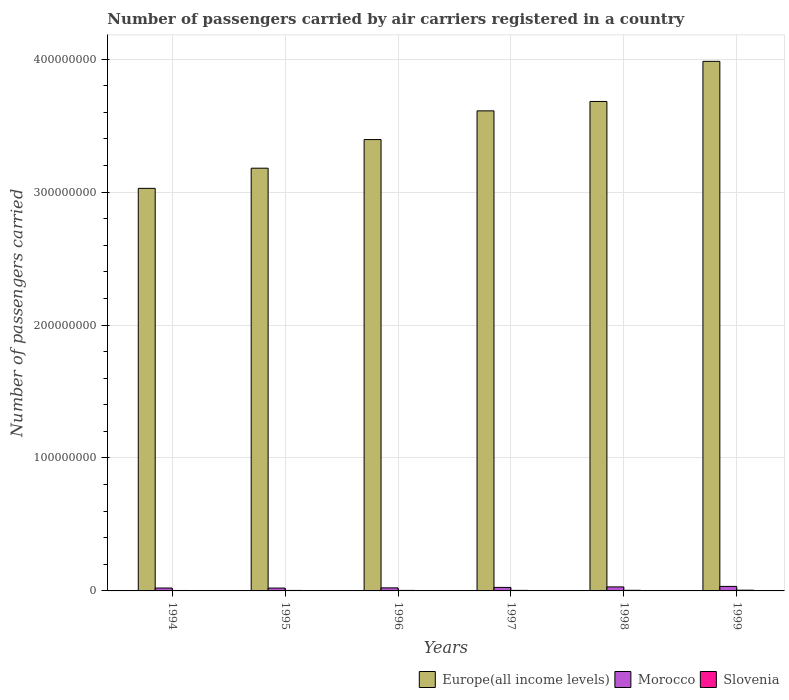How many different coloured bars are there?
Make the answer very short. 3. Are the number of bars per tick equal to the number of legend labels?
Keep it short and to the point. Yes. Are the number of bars on each tick of the X-axis equal?
Provide a short and direct response. Yes. How many bars are there on the 1st tick from the left?
Offer a terse response. 3. What is the label of the 2nd group of bars from the left?
Provide a short and direct response. 1995. What is the number of passengers carried by air carriers in Slovenia in 1995?
Give a very brief answer. 3.71e+05. Across all years, what is the maximum number of passengers carried by air carriers in Morocco?
Provide a succinct answer. 3.39e+06. Across all years, what is the minimum number of passengers carried by air carriers in Slovenia?
Your answer should be compact. 3.40e+05. In which year was the number of passengers carried by air carriers in Slovenia minimum?
Offer a very short reply. 1994. What is the total number of passengers carried by air carriers in Europe(all income levels) in the graph?
Provide a short and direct response. 2.09e+09. What is the difference between the number of passengers carried by air carriers in Europe(all income levels) in 1994 and that in 1997?
Offer a very short reply. -5.83e+07. What is the difference between the number of passengers carried by air carriers in Morocco in 1994 and the number of passengers carried by air carriers in Slovenia in 1995?
Keep it short and to the point. 1.81e+06. What is the average number of passengers carried by air carriers in Europe(all income levels) per year?
Ensure brevity in your answer.  3.48e+08. In the year 1994, what is the difference between the number of passengers carried by air carriers in Slovenia and number of passengers carried by air carriers in Morocco?
Offer a very short reply. -1.84e+06. In how many years, is the number of passengers carried by air carriers in Europe(all income levels) greater than 140000000?
Keep it short and to the point. 6. What is the ratio of the number of passengers carried by air carriers in Morocco in 1997 to that in 1998?
Provide a short and direct response. 0.88. Is the number of passengers carried by air carriers in Slovenia in 1997 less than that in 1998?
Make the answer very short. Yes. Is the difference between the number of passengers carried by air carriers in Slovenia in 1994 and 1995 greater than the difference between the number of passengers carried by air carriers in Morocco in 1994 and 1995?
Provide a succinct answer. No. What is the difference between the highest and the second highest number of passengers carried by air carriers in Morocco?
Your answer should be very brief. 3.80e+05. What is the difference between the highest and the lowest number of passengers carried by air carriers in Morocco?
Your answer should be compact. 1.24e+06. What does the 2nd bar from the left in 1999 represents?
Offer a very short reply. Morocco. What does the 2nd bar from the right in 1997 represents?
Give a very brief answer. Morocco. How many bars are there?
Make the answer very short. 18. Are all the bars in the graph horizontal?
Your answer should be compact. No. How many years are there in the graph?
Your response must be concise. 6. Does the graph contain grids?
Make the answer very short. Yes. Where does the legend appear in the graph?
Keep it short and to the point. Bottom right. How many legend labels are there?
Offer a very short reply. 3. What is the title of the graph?
Provide a short and direct response. Number of passengers carried by air carriers registered in a country. Does "Macao" appear as one of the legend labels in the graph?
Your answer should be very brief. No. What is the label or title of the Y-axis?
Your answer should be very brief. Number of passengers carried. What is the Number of passengers carried in Europe(all income levels) in 1994?
Your response must be concise. 3.03e+08. What is the Number of passengers carried in Morocco in 1994?
Offer a terse response. 2.18e+06. What is the Number of passengers carried of Slovenia in 1994?
Offer a terse response. 3.40e+05. What is the Number of passengers carried of Europe(all income levels) in 1995?
Ensure brevity in your answer.  3.18e+08. What is the Number of passengers carried in Morocco in 1995?
Offer a very short reply. 2.15e+06. What is the Number of passengers carried in Slovenia in 1995?
Ensure brevity in your answer.  3.71e+05. What is the Number of passengers carried in Europe(all income levels) in 1996?
Offer a terse response. 3.40e+08. What is the Number of passengers carried of Morocco in 1996?
Provide a short and direct response. 2.30e+06. What is the Number of passengers carried in Slovenia in 1996?
Ensure brevity in your answer.  3.93e+05. What is the Number of passengers carried in Europe(all income levels) in 1997?
Give a very brief answer. 3.61e+08. What is the Number of passengers carried of Morocco in 1997?
Keep it short and to the point. 2.64e+06. What is the Number of passengers carried in Slovenia in 1997?
Provide a short and direct response. 4.04e+05. What is the Number of passengers carried of Europe(all income levels) in 1998?
Offer a very short reply. 3.68e+08. What is the Number of passengers carried of Morocco in 1998?
Keep it short and to the point. 3.01e+06. What is the Number of passengers carried of Slovenia in 1998?
Give a very brief answer. 4.60e+05. What is the Number of passengers carried in Europe(all income levels) in 1999?
Ensure brevity in your answer.  3.98e+08. What is the Number of passengers carried in Morocco in 1999?
Keep it short and to the point. 3.39e+06. What is the Number of passengers carried of Slovenia in 1999?
Offer a very short reply. 5.56e+05. Across all years, what is the maximum Number of passengers carried in Europe(all income levels)?
Offer a very short reply. 3.98e+08. Across all years, what is the maximum Number of passengers carried in Morocco?
Offer a terse response. 3.39e+06. Across all years, what is the maximum Number of passengers carried in Slovenia?
Offer a terse response. 5.56e+05. Across all years, what is the minimum Number of passengers carried of Europe(all income levels)?
Your response must be concise. 3.03e+08. Across all years, what is the minimum Number of passengers carried in Morocco?
Keep it short and to the point. 2.15e+06. Across all years, what is the minimum Number of passengers carried in Slovenia?
Provide a short and direct response. 3.40e+05. What is the total Number of passengers carried of Europe(all income levels) in the graph?
Your response must be concise. 2.09e+09. What is the total Number of passengers carried of Morocco in the graph?
Provide a succinct answer. 1.57e+07. What is the total Number of passengers carried of Slovenia in the graph?
Your response must be concise. 2.52e+06. What is the difference between the Number of passengers carried in Europe(all income levels) in 1994 and that in 1995?
Your response must be concise. -1.52e+07. What is the difference between the Number of passengers carried in Morocco in 1994 and that in 1995?
Keep it short and to the point. 3.67e+04. What is the difference between the Number of passengers carried in Slovenia in 1994 and that in 1995?
Offer a very short reply. -3.11e+04. What is the difference between the Number of passengers carried of Europe(all income levels) in 1994 and that in 1996?
Provide a succinct answer. -3.67e+07. What is the difference between the Number of passengers carried in Morocco in 1994 and that in 1996?
Your answer should be compact. -1.17e+05. What is the difference between the Number of passengers carried in Slovenia in 1994 and that in 1996?
Offer a terse response. -5.34e+04. What is the difference between the Number of passengers carried of Europe(all income levels) in 1994 and that in 1997?
Provide a short and direct response. -5.83e+07. What is the difference between the Number of passengers carried in Morocco in 1994 and that in 1997?
Keep it short and to the point. -4.54e+05. What is the difference between the Number of passengers carried in Slovenia in 1994 and that in 1997?
Your answer should be compact. -6.42e+04. What is the difference between the Number of passengers carried of Europe(all income levels) in 1994 and that in 1998?
Your answer should be very brief. -6.54e+07. What is the difference between the Number of passengers carried of Morocco in 1994 and that in 1998?
Your answer should be very brief. -8.28e+05. What is the difference between the Number of passengers carried of Slovenia in 1994 and that in 1998?
Make the answer very short. -1.20e+05. What is the difference between the Number of passengers carried in Europe(all income levels) in 1994 and that in 1999?
Offer a very short reply. -9.55e+07. What is the difference between the Number of passengers carried of Morocco in 1994 and that in 1999?
Your response must be concise. -1.21e+06. What is the difference between the Number of passengers carried of Slovenia in 1994 and that in 1999?
Ensure brevity in your answer.  -2.16e+05. What is the difference between the Number of passengers carried in Europe(all income levels) in 1995 and that in 1996?
Provide a succinct answer. -2.15e+07. What is the difference between the Number of passengers carried of Morocco in 1995 and that in 1996?
Keep it short and to the point. -1.54e+05. What is the difference between the Number of passengers carried of Slovenia in 1995 and that in 1996?
Your answer should be compact. -2.23e+04. What is the difference between the Number of passengers carried in Europe(all income levels) in 1995 and that in 1997?
Make the answer very short. -4.31e+07. What is the difference between the Number of passengers carried of Morocco in 1995 and that in 1997?
Your answer should be very brief. -4.91e+05. What is the difference between the Number of passengers carried in Slovenia in 1995 and that in 1997?
Your answer should be very brief. -3.31e+04. What is the difference between the Number of passengers carried of Europe(all income levels) in 1995 and that in 1998?
Provide a succinct answer. -5.02e+07. What is the difference between the Number of passengers carried in Morocco in 1995 and that in 1998?
Your answer should be compact. -8.65e+05. What is the difference between the Number of passengers carried of Slovenia in 1995 and that in 1998?
Give a very brief answer. -8.92e+04. What is the difference between the Number of passengers carried in Europe(all income levels) in 1995 and that in 1999?
Provide a short and direct response. -8.04e+07. What is the difference between the Number of passengers carried of Morocco in 1995 and that in 1999?
Give a very brief answer. -1.24e+06. What is the difference between the Number of passengers carried of Slovenia in 1995 and that in 1999?
Provide a short and direct response. -1.85e+05. What is the difference between the Number of passengers carried of Europe(all income levels) in 1996 and that in 1997?
Give a very brief answer. -2.16e+07. What is the difference between the Number of passengers carried in Morocco in 1996 and that in 1997?
Offer a very short reply. -3.37e+05. What is the difference between the Number of passengers carried of Slovenia in 1996 and that in 1997?
Give a very brief answer. -1.08e+04. What is the difference between the Number of passengers carried of Europe(all income levels) in 1996 and that in 1998?
Your response must be concise. -2.87e+07. What is the difference between the Number of passengers carried of Morocco in 1996 and that in 1998?
Provide a succinct answer. -7.11e+05. What is the difference between the Number of passengers carried of Slovenia in 1996 and that in 1998?
Offer a terse response. -6.69e+04. What is the difference between the Number of passengers carried in Europe(all income levels) in 1996 and that in 1999?
Offer a terse response. -5.88e+07. What is the difference between the Number of passengers carried of Morocco in 1996 and that in 1999?
Provide a short and direct response. -1.09e+06. What is the difference between the Number of passengers carried in Slovenia in 1996 and that in 1999?
Provide a succinct answer. -1.62e+05. What is the difference between the Number of passengers carried in Europe(all income levels) in 1997 and that in 1998?
Provide a short and direct response. -7.08e+06. What is the difference between the Number of passengers carried in Morocco in 1997 and that in 1998?
Make the answer very short. -3.74e+05. What is the difference between the Number of passengers carried of Slovenia in 1997 and that in 1998?
Give a very brief answer. -5.61e+04. What is the difference between the Number of passengers carried in Europe(all income levels) in 1997 and that in 1999?
Your response must be concise. -3.72e+07. What is the difference between the Number of passengers carried of Morocco in 1997 and that in 1999?
Provide a succinct answer. -7.54e+05. What is the difference between the Number of passengers carried in Slovenia in 1997 and that in 1999?
Offer a terse response. -1.52e+05. What is the difference between the Number of passengers carried of Europe(all income levels) in 1998 and that in 1999?
Make the answer very short. -3.02e+07. What is the difference between the Number of passengers carried in Morocco in 1998 and that in 1999?
Ensure brevity in your answer.  -3.80e+05. What is the difference between the Number of passengers carried of Slovenia in 1998 and that in 1999?
Your response must be concise. -9.56e+04. What is the difference between the Number of passengers carried in Europe(all income levels) in 1994 and the Number of passengers carried in Morocco in 1995?
Ensure brevity in your answer.  3.01e+08. What is the difference between the Number of passengers carried of Europe(all income levels) in 1994 and the Number of passengers carried of Slovenia in 1995?
Your response must be concise. 3.02e+08. What is the difference between the Number of passengers carried of Morocco in 1994 and the Number of passengers carried of Slovenia in 1995?
Your answer should be very brief. 1.81e+06. What is the difference between the Number of passengers carried in Europe(all income levels) in 1994 and the Number of passengers carried in Morocco in 1996?
Provide a succinct answer. 3.01e+08. What is the difference between the Number of passengers carried in Europe(all income levels) in 1994 and the Number of passengers carried in Slovenia in 1996?
Provide a short and direct response. 3.02e+08. What is the difference between the Number of passengers carried of Morocco in 1994 and the Number of passengers carried of Slovenia in 1996?
Your answer should be compact. 1.79e+06. What is the difference between the Number of passengers carried in Europe(all income levels) in 1994 and the Number of passengers carried in Morocco in 1997?
Give a very brief answer. 3.00e+08. What is the difference between the Number of passengers carried of Europe(all income levels) in 1994 and the Number of passengers carried of Slovenia in 1997?
Your answer should be very brief. 3.02e+08. What is the difference between the Number of passengers carried in Morocco in 1994 and the Number of passengers carried in Slovenia in 1997?
Offer a very short reply. 1.78e+06. What is the difference between the Number of passengers carried in Europe(all income levels) in 1994 and the Number of passengers carried in Morocco in 1998?
Your answer should be very brief. 3.00e+08. What is the difference between the Number of passengers carried in Europe(all income levels) in 1994 and the Number of passengers carried in Slovenia in 1998?
Make the answer very short. 3.02e+08. What is the difference between the Number of passengers carried of Morocco in 1994 and the Number of passengers carried of Slovenia in 1998?
Offer a terse response. 1.72e+06. What is the difference between the Number of passengers carried of Europe(all income levels) in 1994 and the Number of passengers carried of Morocco in 1999?
Your answer should be very brief. 2.99e+08. What is the difference between the Number of passengers carried of Europe(all income levels) in 1994 and the Number of passengers carried of Slovenia in 1999?
Your response must be concise. 3.02e+08. What is the difference between the Number of passengers carried of Morocco in 1994 and the Number of passengers carried of Slovenia in 1999?
Make the answer very short. 1.63e+06. What is the difference between the Number of passengers carried of Europe(all income levels) in 1995 and the Number of passengers carried of Morocco in 1996?
Offer a terse response. 3.16e+08. What is the difference between the Number of passengers carried in Europe(all income levels) in 1995 and the Number of passengers carried in Slovenia in 1996?
Give a very brief answer. 3.18e+08. What is the difference between the Number of passengers carried in Morocco in 1995 and the Number of passengers carried in Slovenia in 1996?
Offer a very short reply. 1.75e+06. What is the difference between the Number of passengers carried of Europe(all income levels) in 1995 and the Number of passengers carried of Morocco in 1997?
Offer a very short reply. 3.15e+08. What is the difference between the Number of passengers carried in Europe(all income levels) in 1995 and the Number of passengers carried in Slovenia in 1997?
Keep it short and to the point. 3.18e+08. What is the difference between the Number of passengers carried in Morocco in 1995 and the Number of passengers carried in Slovenia in 1997?
Your answer should be compact. 1.74e+06. What is the difference between the Number of passengers carried in Europe(all income levels) in 1995 and the Number of passengers carried in Morocco in 1998?
Offer a very short reply. 3.15e+08. What is the difference between the Number of passengers carried in Europe(all income levels) in 1995 and the Number of passengers carried in Slovenia in 1998?
Offer a terse response. 3.18e+08. What is the difference between the Number of passengers carried in Morocco in 1995 and the Number of passengers carried in Slovenia in 1998?
Give a very brief answer. 1.69e+06. What is the difference between the Number of passengers carried of Europe(all income levels) in 1995 and the Number of passengers carried of Morocco in 1999?
Provide a short and direct response. 3.15e+08. What is the difference between the Number of passengers carried in Europe(all income levels) in 1995 and the Number of passengers carried in Slovenia in 1999?
Provide a succinct answer. 3.17e+08. What is the difference between the Number of passengers carried in Morocco in 1995 and the Number of passengers carried in Slovenia in 1999?
Ensure brevity in your answer.  1.59e+06. What is the difference between the Number of passengers carried in Europe(all income levels) in 1996 and the Number of passengers carried in Morocco in 1997?
Provide a short and direct response. 3.37e+08. What is the difference between the Number of passengers carried in Europe(all income levels) in 1996 and the Number of passengers carried in Slovenia in 1997?
Offer a very short reply. 3.39e+08. What is the difference between the Number of passengers carried of Morocco in 1996 and the Number of passengers carried of Slovenia in 1997?
Offer a very short reply. 1.90e+06. What is the difference between the Number of passengers carried in Europe(all income levels) in 1996 and the Number of passengers carried in Morocco in 1998?
Offer a terse response. 3.37e+08. What is the difference between the Number of passengers carried in Europe(all income levels) in 1996 and the Number of passengers carried in Slovenia in 1998?
Ensure brevity in your answer.  3.39e+08. What is the difference between the Number of passengers carried of Morocco in 1996 and the Number of passengers carried of Slovenia in 1998?
Offer a terse response. 1.84e+06. What is the difference between the Number of passengers carried in Europe(all income levels) in 1996 and the Number of passengers carried in Morocco in 1999?
Your answer should be very brief. 3.36e+08. What is the difference between the Number of passengers carried of Europe(all income levels) in 1996 and the Number of passengers carried of Slovenia in 1999?
Provide a short and direct response. 3.39e+08. What is the difference between the Number of passengers carried of Morocco in 1996 and the Number of passengers carried of Slovenia in 1999?
Ensure brevity in your answer.  1.75e+06. What is the difference between the Number of passengers carried in Europe(all income levels) in 1997 and the Number of passengers carried in Morocco in 1998?
Your answer should be compact. 3.58e+08. What is the difference between the Number of passengers carried of Europe(all income levels) in 1997 and the Number of passengers carried of Slovenia in 1998?
Make the answer very short. 3.61e+08. What is the difference between the Number of passengers carried in Morocco in 1997 and the Number of passengers carried in Slovenia in 1998?
Your response must be concise. 2.18e+06. What is the difference between the Number of passengers carried in Europe(all income levels) in 1997 and the Number of passengers carried in Morocco in 1999?
Your answer should be compact. 3.58e+08. What is the difference between the Number of passengers carried of Europe(all income levels) in 1997 and the Number of passengers carried of Slovenia in 1999?
Make the answer very short. 3.61e+08. What is the difference between the Number of passengers carried in Morocco in 1997 and the Number of passengers carried in Slovenia in 1999?
Make the answer very short. 2.08e+06. What is the difference between the Number of passengers carried of Europe(all income levels) in 1998 and the Number of passengers carried of Morocco in 1999?
Give a very brief answer. 3.65e+08. What is the difference between the Number of passengers carried in Europe(all income levels) in 1998 and the Number of passengers carried in Slovenia in 1999?
Your answer should be very brief. 3.68e+08. What is the difference between the Number of passengers carried in Morocco in 1998 and the Number of passengers carried in Slovenia in 1999?
Ensure brevity in your answer.  2.46e+06. What is the average Number of passengers carried in Europe(all income levels) per year?
Your answer should be very brief. 3.48e+08. What is the average Number of passengers carried of Morocco per year?
Provide a short and direct response. 2.61e+06. What is the average Number of passengers carried of Slovenia per year?
Offer a very short reply. 4.20e+05. In the year 1994, what is the difference between the Number of passengers carried of Europe(all income levels) and Number of passengers carried of Morocco?
Provide a succinct answer. 3.01e+08. In the year 1994, what is the difference between the Number of passengers carried of Europe(all income levels) and Number of passengers carried of Slovenia?
Provide a short and direct response. 3.03e+08. In the year 1994, what is the difference between the Number of passengers carried of Morocco and Number of passengers carried of Slovenia?
Your answer should be compact. 1.84e+06. In the year 1995, what is the difference between the Number of passengers carried in Europe(all income levels) and Number of passengers carried in Morocco?
Offer a very short reply. 3.16e+08. In the year 1995, what is the difference between the Number of passengers carried of Europe(all income levels) and Number of passengers carried of Slovenia?
Give a very brief answer. 3.18e+08. In the year 1995, what is the difference between the Number of passengers carried of Morocco and Number of passengers carried of Slovenia?
Ensure brevity in your answer.  1.78e+06. In the year 1996, what is the difference between the Number of passengers carried in Europe(all income levels) and Number of passengers carried in Morocco?
Make the answer very short. 3.37e+08. In the year 1996, what is the difference between the Number of passengers carried in Europe(all income levels) and Number of passengers carried in Slovenia?
Make the answer very short. 3.39e+08. In the year 1996, what is the difference between the Number of passengers carried in Morocco and Number of passengers carried in Slovenia?
Offer a terse response. 1.91e+06. In the year 1997, what is the difference between the Number of passengers carried in Europe(all income levels) and Number of passengers carried in Morocco?
Make the answer very short. 3.59e+08. In the year 1997, what is the difference between the Number of passengers carried in Europe(all income levels) and Number of passengers carried in Slovenia?
Give a very brief answer. 3.61e+08. In the year 1997, what is the difference between the Number of passengers carried of Morocco and Number of passengers carried of Slovenia?
Provide a short and direct response. 2.23e+06. In the year 1998, what is the difference between the Number of passengers carried of Europe(all income levels) and Number of passengers carried of Morocco?
Provide a succinct answer. 3.65e+08. In the year 1998, what is the difference between the Number of passengers carried in Europe(all income levels) and Number of passengers carried in Slovenia?
Offer a terse response. 3.68e+08. In the year 1998, what is the difference between the Number of passengers carried in Morocco and Number of passengers carried in Slovenia?
Your response must be concise. 2.55e+06. In the year 1999, what is the difference between the Number of passengers carried in Europe(all income levels) and Number of passengers carried in Morocco?
Ensure brevity in your answer.  3.95e+08. In the year 1999, what is the difference between the Number of passengers carried of Europe(all income levels) and Number of passengers carried of Slovenia?
Keep it short and to the point. 3.98e+08. In the year 1999, what is the difference between the Number of passengers carried in Morocco and Number of passengers carried in Slovenia?
Provide a short and direct response. 2.84e+06. What is the ratio of the Number of passengers carried of Europe(all income levels) in 1994 to that in 1995?
Ensure brevity in your answer.  0.95. What is the ratio of the Number of passengers carried in Morocco in 1994 to that in 1995?
Make the answer very short. 1.02. What is the ratio of the Number of passengers carried in Slovenia in 1994 to that in 1995?
Provide a short and direct response. 0.92. What is the ratio of the Number of passengers carried in Europe(all income levels) in 1994 to that in 1996?
Give a very brief answer. 0.89. What is the ratio of the Number of passengers carried of Morocco in 1994 to that in 1996?
Provide a succinct answer. 0.95. What is the ratio of the Number of passengers carried in Slovenia in 1994 to that in 1996?
Give a very brief answer. 0.86. What is the ratio of the Number of passengers carried of Europe(all income levels) in 1994 to that in 1997?
Offer a very short reply. 0.84. What is the ratio of the Number of passengers carried of Morocco in 1994 to that in 1997?
Keep it short and to the point. 0.83. What is the ratio of the Number of passengers carried in Slovenia in 1994 to that in 1997?
Offer a terse response. 0.84. What is the ratio of the Number of passengers carried of Europe(all income levels) in 1994 to that in 1998?
Your answer should be very brief. 0.82. What is the ratio of the Number of passengers carried of Morocco in 1994 to that in 1998?
Make the answer very short. 0.73. What is the ratio of the Number of passengers carried of Slovenia in 1994 to that in 1998?
Keep it short and to the point. 0.74. What is the ratio of the Number of passengers carried in Europe(all income levels) in 1994 to that in 1999?
Your answer should be compact. 0.76. What is the ratio of the Number of passengers carried of Morocco in 1994 to that in 1999?
Offer a terse response. 0.64. What is the ratio of the Number of passengers carried of Slovenia in 1994 to that in 1999?
Make the answer very short. 0.61. What is the ratio of the Number of passengers carried of Europe(all income levels) in 1995 to that in 1996?
Your answer should be very brief. 0.94. What is the ratio of the Number of passengers carried of Morocco in 1995 to that in 1996?
Provide a short and direct response. 0.93. What is the ratio of the Number of passengers carried of Slovenia in 1995 to that in 1996?
Ensure brevity in your answer.  0.94. What is the ratio of the Number of passengers carried in Europe(all income levels) in 1995 to that in 1997?
Make the answer very short. 0.88. What is the ratio of the Number of passengers carried in Morocco in 1995 to that in 1997?
Ensure brevity in your answer.  0.81. What is the ratio of the Number of passengers carried of Slovenia in 1995 to that in 1997?
Give a very brief answer. 0.92. What is the ratio of the Number of passengers carried of Europe(all income levels) in 1995 to that in 1998?
Offer a terse response. 0.86. What is the ratio of the Number of passengers carried of Morocco in 1995 to that in 1998?
Your answer should be compact. 0.71. What is the ratio of the Number of passengers carried of Slovenia in 1995 to that in 1998?
Your answer should be very brief. 0.81. What is the ratio of the Number of passengers carried of Europe(all income levels) in 1995 to that in 1999?
Your answer should be compact. 0.8. What is the ratio of the Number of passengers carried of Morocco in 1995 to that in 1999?
Your answer should be very brief. 0.63. What is the ratio of the Number of passengers carried of Slovenia in 1995 to that in 1999?
Offer a terse response. 0.67. What is the ratio of the Number of passengers carried of Europe(all income levels) in 1996 to that in 1997?
Ensure brevity in your answer.  0.94. What is the ratio of the Number of passengers carried of Morocco in 1996 to that in 1997?
Keep it short and to the point. 0.87. What is the ratio of the Number of passengers carried in Slovenia in 1996 to that in 1997?
Keep it short and to the point. 0.97. What is the ratio of the Number of passengers carried of Europe(all income levels) in 1996 to that in 1998?
Offer a terse response. 0.92. What is the ratio of the Number of passengers carried in Morocco in 1996 to that in 1998?
Offer a very short reply. 0.76. What is the ratio of the Number of passengers carried in Slovenia in 1996 to that in 1998?
Make the answer very short. 0.85. What is the ratio of the Number of passengers carried of Europe(all income levels) in 1996 to that in 1999?
Make the answer very short. 0.85. What is the ratio of the Number of passengers carried in Morocco in 1996 to that in 1999?
Offer a terse response. 0.68. What is the ratio of the Number of passengers carried of Slovenia in 1996 to that in 1999?
Offer a terse response. 0.71. What is the ratio of the Number of passengers carried of Europe(all income levels) in 1997 to that in 1998?
Your answer should be compact. 0.98. What is the ratio of the Number of passengers carried in Morocco in 1997 to that in 1998?
Offer a terse response. 0.88. What is the ratio of the Number of passengers carried of Slovenia in 1997 to that in 1998?
Make the answer very short. 0.88. What is the ratio of the Number of passengers carried of Europe(all income levels) in 1997 to that in 1999?
Offer a very short reply. 0.91. What is the ratio of the Number of passengers carried of Slovenia in 1997 to that in 1999?
Give a very brief answer. 0.73. What is the ratio of the Number of passengers carried in Europe(all income levels) in 1998 to that in 1999?
Your answer should be very brief. 0.92. What is the ratio of the Number of passengers carried of Morocco in 1998 to that in 1999?
Your response must be concise. 0.89. What is the ratio of the Number of passengers carried in Slovenia in 1998 to that in 1999?
Your response must be concise. 0.83. What is the difference between the highest and the second highest Number of passengers carried in Europe(all income levels)?
Your answer should be compact. 3.02e+07. What is the difference between the highest and the second highest Number of passengers carried in Morocco?
Keep it short and to the point. 3.80e+05. What is the difference between the highest and the second highest Number of passengers carried of Slovenia?
Make the answer very short. 9.56e+04. What is the difference between the highest and the lowest Number of passengers carried in Europe(all income levels)?
Provide a succinct answer. 9.55e+07. What is the difference between the highest and the lowest Number of passengers carried of Morocco?
Offer a very short reply. 1.24e+06. What is the difference between the highest and the lowest Number of passengers carried in Slovenia?
Make the answer very short. 2.16e+05. 